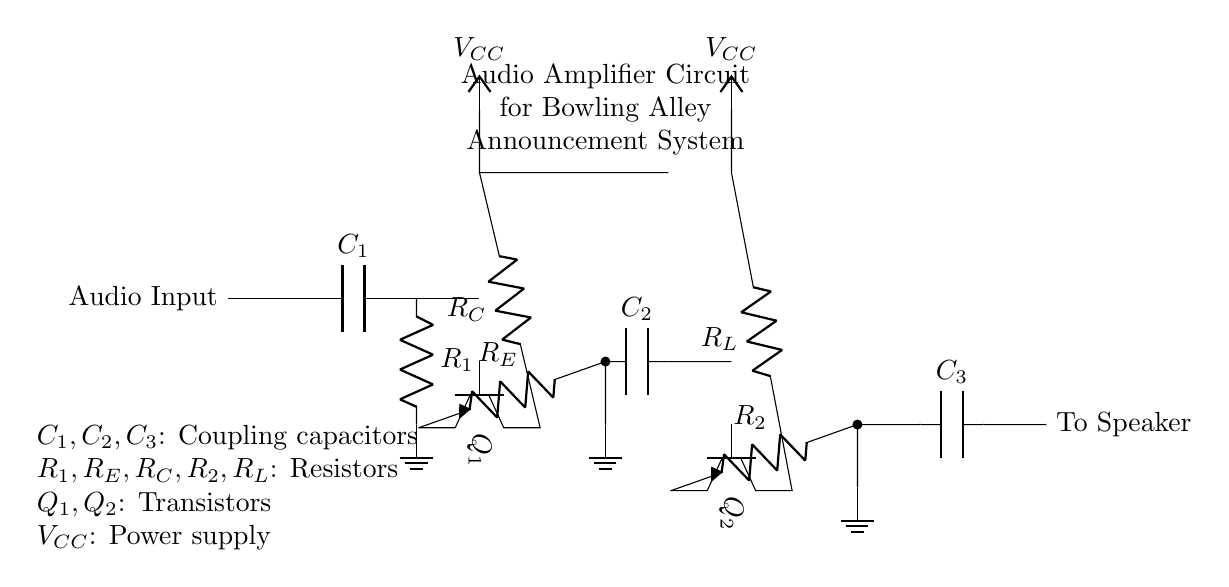What is the function of capacitor C1? Capacitor C1 serves as a coupling capacitor, allowing AC signals from the audio input to pass while blocking DC. This ensures that only the desired audio signal reaches the next stage of the amplifier.
Answer: Coupling capacitor What type of transistors are used in this amplifier circuit? The circuit uses npn transistors, as indicated by the npn notation next to the transistors in the diagram. This type is typically used for amplifying or switching signals.
Answer: npn What does VCC represent in the circuit? VCC represents the power supply voltage that provides the necessary energy for the transistors to function and boost the audio signal. Both transistors have a connection to VCC, ensuring they operate correctly.
Answer: Power supply voltage What would happen if resistor R1 were to fail? If resistor R1 were to fail, the pre-amp stage would not bias the transistor Q1 properly, potentially preventing the amplifier from processing the audio signal effectively. This could lead to silence or distortion in the output.
Answer: Loss of amplification How is feedback established in the circuit? Negative feedback is established through resistor RE connected to the emitter of transistor Q1. This feedback helps stabilize the gain and improves linearity in the circuit's response.
Answer: Negative feedback What is the role of C2 in the circuit? Capacitor C2 serves as a coupling capacitor that transfers the amplified audio signal from the transistor Q1 to the input of the power amplifier stage, while again blocking any DC components in the signal.
Answer: Coupling capacitor 